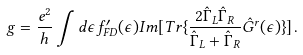<formula> <loc_0><loc_0><loc_500><loc_500>g = \frac { e ^ { 2 } } { h } \int d \epsilon f ^ { \prime } _ { F D } ( \epsilon ) I m [ T r \{ \frac { 2 \hat { \Gamma } _ { L } \hat { \Gamma } _ { R } } { \hat { \Gamma } _ { L } + \hat { \Gamma } _ { R } } \hat { G } ^ { r } ( \epsilon ) \} ] \, .</formula> 